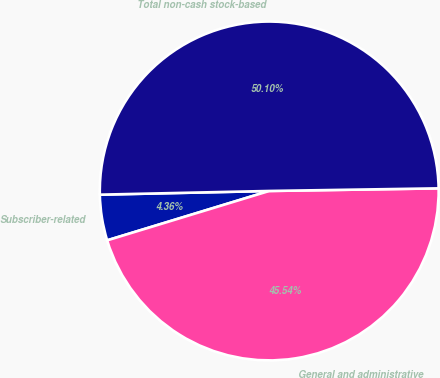Convert chart to OTSL. <chart><loc_0><loc_0><loc_500><loc_500><pie_chart><fcel>Subscriber-related<fcel>General and administrative<fcel>Total non-cash stock-based<nl><fcel>4.36%<fcel>45.54%<fcel>50.1%<nl></chart> 